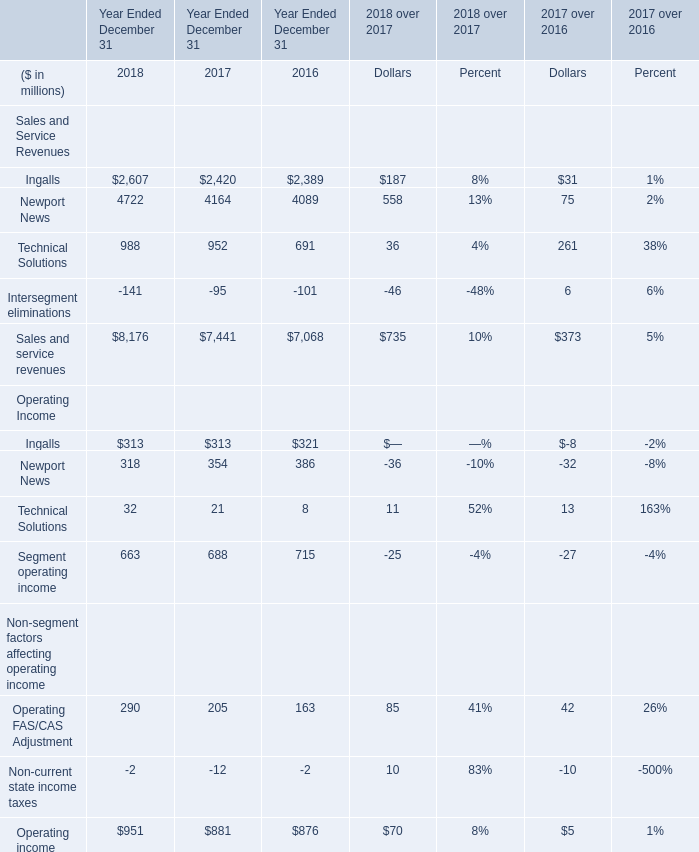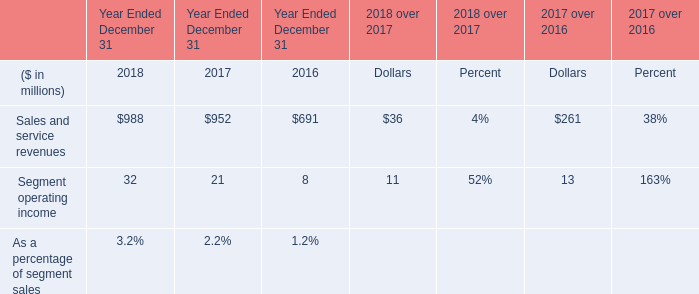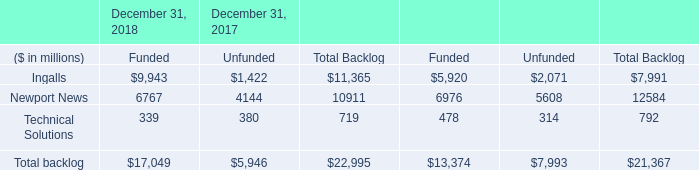What's the sum of Newport News of December 31, 2017 Funded, and Newport News of Year Ended December 31 2016 ? 
Computations: (6976.0 + 4089.0)
Answer: 11065.0. 